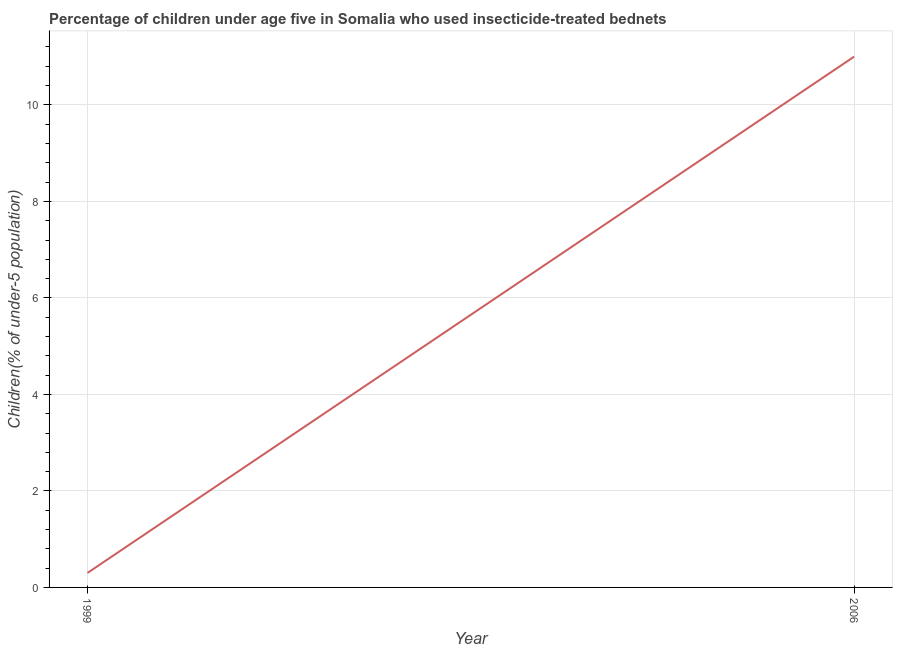What is the percentage of children who use of insecticide-treated bed nets in 2006?
Ensure brevity in your answer.  11. Across all years, what is the minimum percentage of children who use of insecticide-treated bed nets?
Make the answer very short. 0.3. In which year was the percentage of children who use of insecticide-treated bed nets maximum?
Provide a short and direct response. 2006. What is the sum of the percentage of children who use of insecticide-treated bed nets?
Offer a terse response. 11.3. What is the difference between the percentage of children who use of insecticide-treated bed nets in 1999 and 2006?
Ensure brevity in your answer.  -10.7. What is the average percentage of children who use of insecticide-treated bed nets per year?
Ensure brevity in your answer.  5.65. What is the median percentage of children who use of insecticide-treated bed nets?
Your answer should be compact. 5.65. In how many years, is the percentage of children who use of insecticide-treated bed nets greater than 2.8 %?
Ensure brevity in your answer.  1. What is the ratio of the percentage of children who use of insecticide-treated bed nets in 1999 to that in 2006?
Offer a very short reply. 0.03. Is the percentage of children who use of insecticide-treated bed nets in 1999 less than that in 2006?
Your answer should be compact. Yes. Does the percentage of children who use of insecticide-treated bed nets monotonically increase over the years?
Your answer should be very brief. Yes. How many years are there in the graph?
Keep it short and to the point. 2. Does the graph contain any zero values?
Your answer should be very brief. No. Does the graph contain grids?
Provide a succinct answer. Yes. What is the title of the graph?
Make the answer very short. Percentage of children under age five in Somalia who used insecticide-treated bednets. What is the label or title of the X-axis?
Your answer should be compact. Year. What is the label or title of the Y-axis?
Keep it short and to the point. Children(% of under-5 population). What is the Children(% of under-5 population) in 1999?
Offer a terse response. 0.3. What is the Children(% of under-5 population) in 2006?
Ensure brevity in your answer.  11. What is the difference between the Children(% of under-5 population) in 1999 and 2006?
Provide a short and direct response. -10.7. What is the ratio of the Children(% of under-5 population) in 1999 to that in 2006?
Your response must be concise. 0.03. 